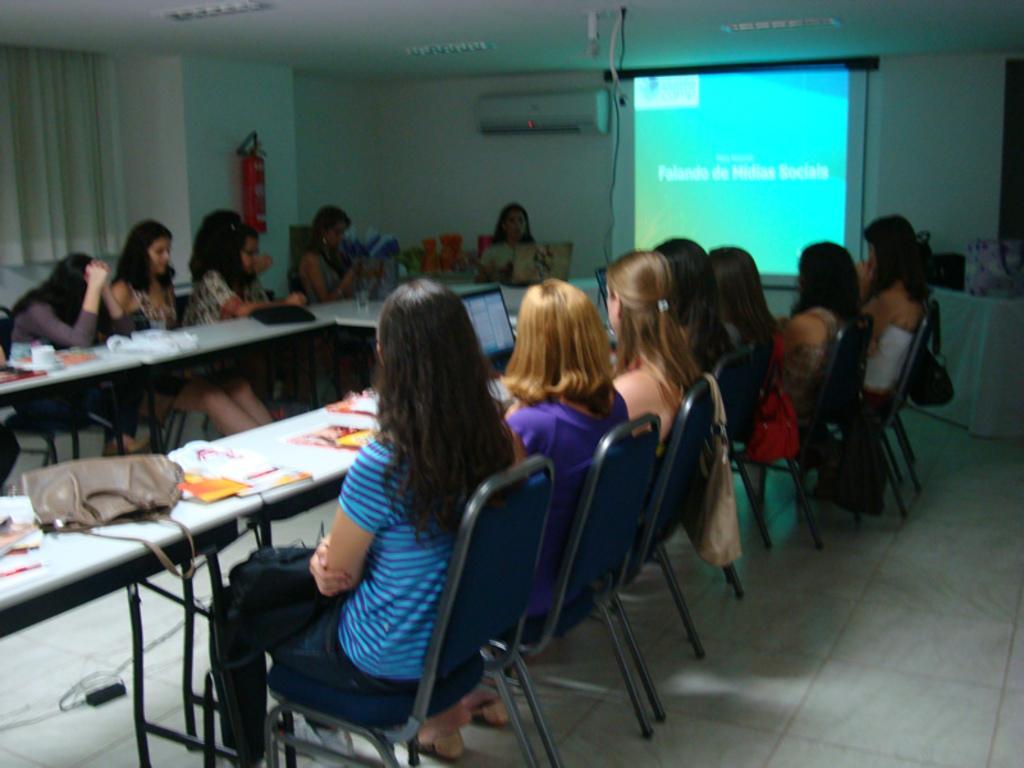How would you summarize this image in a sentence or two? In this picture we can see a group of people sitting on chair and in front of them there is table and on table we can see papers, bag, laptop and in background we can see screen, AC, wall, fire extinguisher, curtains. 